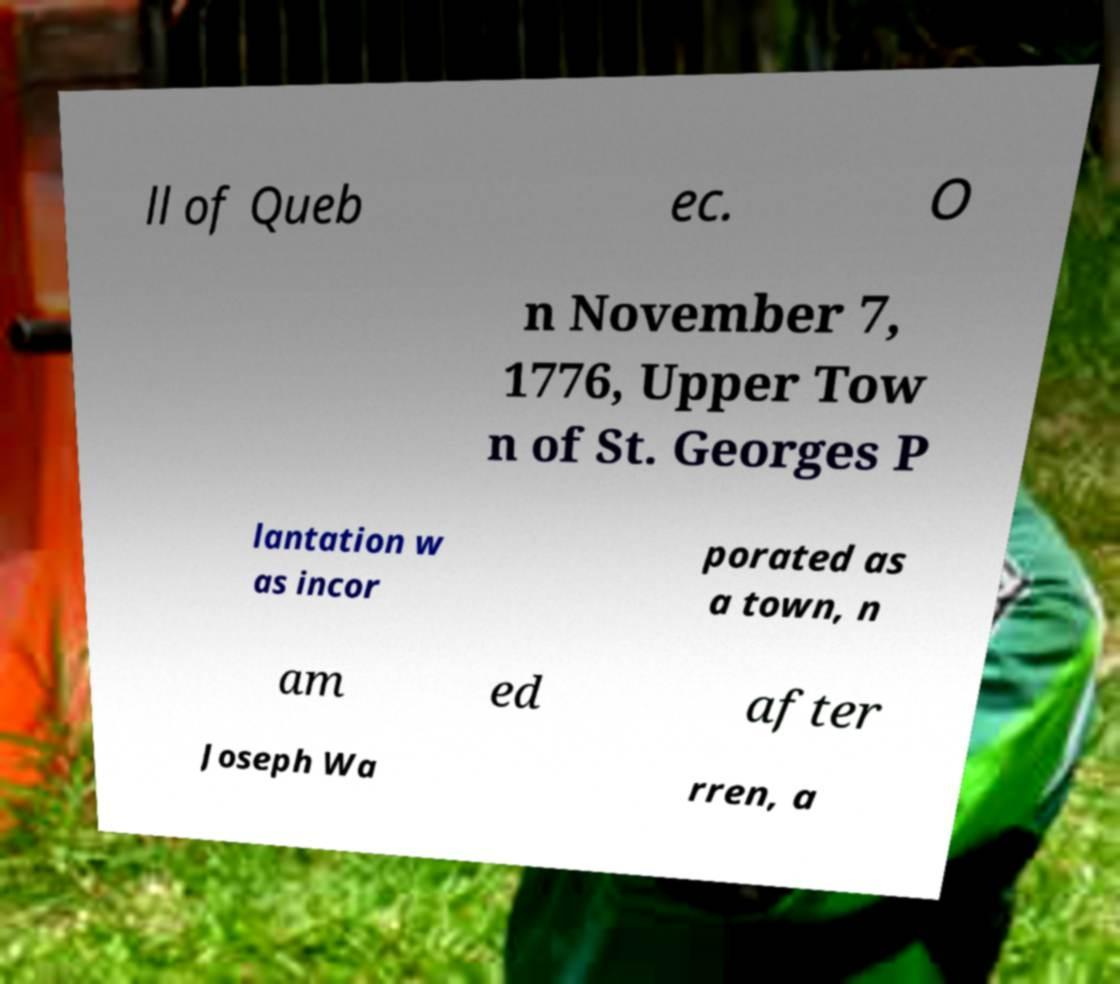Can you read and provide the text displayed in the image?This photo seems to have some interesting text. Can you extract and type it out for me? ll of Queb ec. O n November 7, 1776, Upper Tow n of St. Georges P lantation w as incor porated as a town, n am ed after Joseph Wa rren, a 